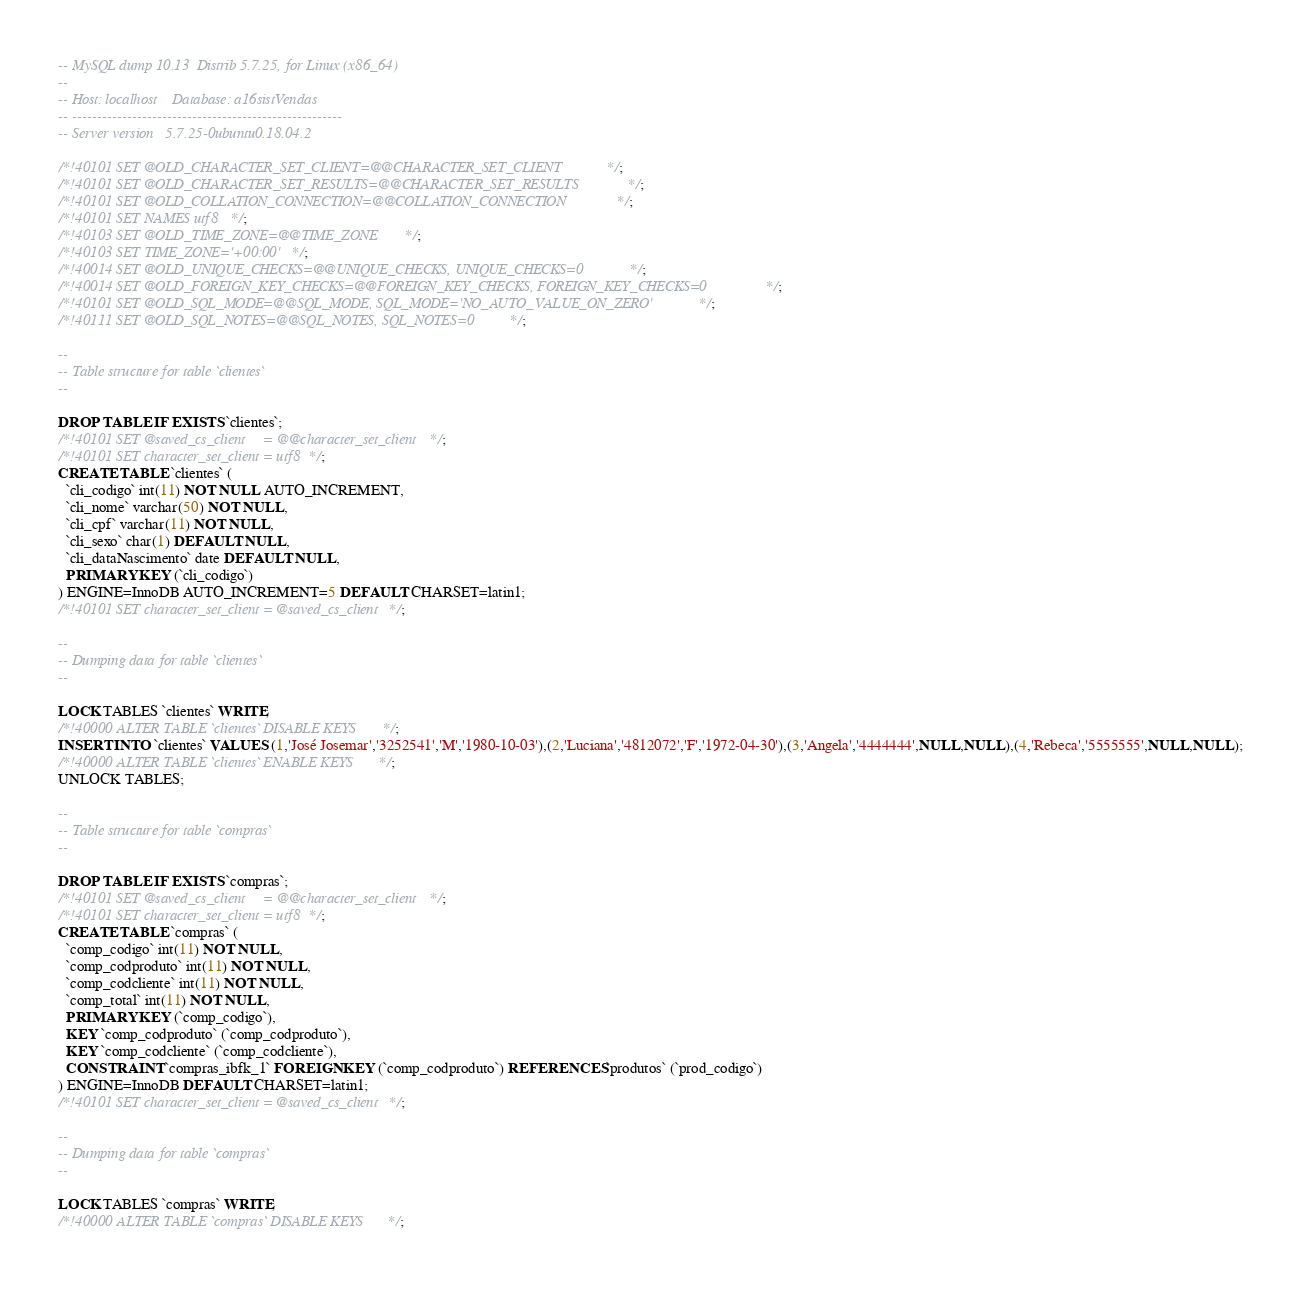Convert code to text. <code><loc_0><loc_0><loc_500><loc_500><_SQL_>-- MySQL dump 10.13  Distrib 5.7.25, for Linux (x86_64)
--
-- Host: localhost    Database: a16sistVendas
-- ------------------------------------------------------
-- Server version	5.7.25-0ubuntu0.18.04.2

/*!40101 SET @OLD_CHARACTER_SET_CLIENT=@@CHARACTER_SET_CLIENT */;
/*!40101 SET @OLD_CHARACTER_SET_RESULTS=@@CHARACTER_SET_RESULTS */;
/*!40101 SET @OLD_COLLATION_CONNECTION=@@COLLATION_CONNECTION */;
/*!40101 SET NAMES utf8 */;
/*!40103 SET @OLD_TIME_ZONE=@@TIME_ZONE */;
/*!40103 SET TIME_ZONE='+00:00' */;
/*!40014 SET @OLD_UNIQUE_CHECKS=@@UNIQUE_CHECKS, UNIQUE_CHECKS=0 */;
/*!40014 SET @OLD_FOREIGN_KEY_CHECKS=@@FOREIGN_KEY_CHECKS, FOREIGN_KEY_CHECKS=0 */;
/*!40101 SET @OLD_SQL_MODE=@@SQL_MODE, SQL_MODE='NO_AUTO_VALUE_ON_ZERO' */;
/*!40111 SET @OLD_SQL_NOTES=@@SQL_NOTES, SQL_NOTES=0 */;

--
-- Table structure for table `clientes`
--

DROP TABLE IF EXISTS `clientes`;
/*!40101 SET @saved_cs_client     = @@character_set_client */;
/*!40101 SET character_set_client = utf8 */;
CREATE TABLE `clientes` (
  `cli_codigo` int(11) NOT NULL AUTO_INCREMENT,
  `cli_nome` varchar(50) NOT NULL,
  `cli_cpf` varchar(11) NOT NULL,
  `cli_sexo` char(1) DEFAULT NULL,
  `cli_dataNascimento` date DEFAULT NULL,
  PRIMARY KEY (`cli_codigo`)
) ENGINE=InnoDB AUTO_INCREMENT=5 DEFAULT CHARSET=latin1;
/*!40101 SET character_set_client = @saved_cs_client */;

--
-- Dumping data for table `clientes`
--

LOCK TABLES `clientes` WRITE;
/*!40000 ALTER TABLE `clientes` DISABLE KEYS */;
INSERT INTO `clientes` VALUES (1,'José Josemar','3252541','M','1980-10-03'),(2,'Luciana','4812072','F','1972-04-30'),(3,'Angela','4444444',NULL,NULL),(4,'Rebeca','5555555',NULL,NULL);
/*!40000 ALTER TABLE `clientes` ENABLE KEYS */;
UNLOCK TABLES;

--
-- Table structure for table `compras`
--

DROP TABLE IF EXISTS `compras`;
/*!40101 SET @saved_cs_client     = @@character_set_client */;
/*!40101 SET character_set_client = utf8 */;
CREATE TABLE `compras` (
  `comp_codigo` int(11) NOT NULL,
  `comp_codproduto` int(11) NOT NULL,
  `comp_codcliente` int(11) NOT NULL,
  `comp_total` int(11) NOT NULL,
  PRIMARY KEY (`comp_codigo`),
  KEY `comp_codproduto` (`comp_codproduto`),
  KEY `comp_codcliente` (`comp_codcliente`),
  CONSTRAINT `compras_ibfk_1` FOREIGN KEY (`comp_codproduto`) REFERENCES `produtos` (`prod_codigo`)
) ENGINE=InnoDB DEFAULT CHARSET=latin1;
/*!40101 SET character_set_client = @saved_cs_client */;

--
-- Dumping data for table `compras`
--

LOCK TABLES `compras` WRITE;
/*!40000 ALTER TABLE `compras` DISABLE KEYS */;</code> 